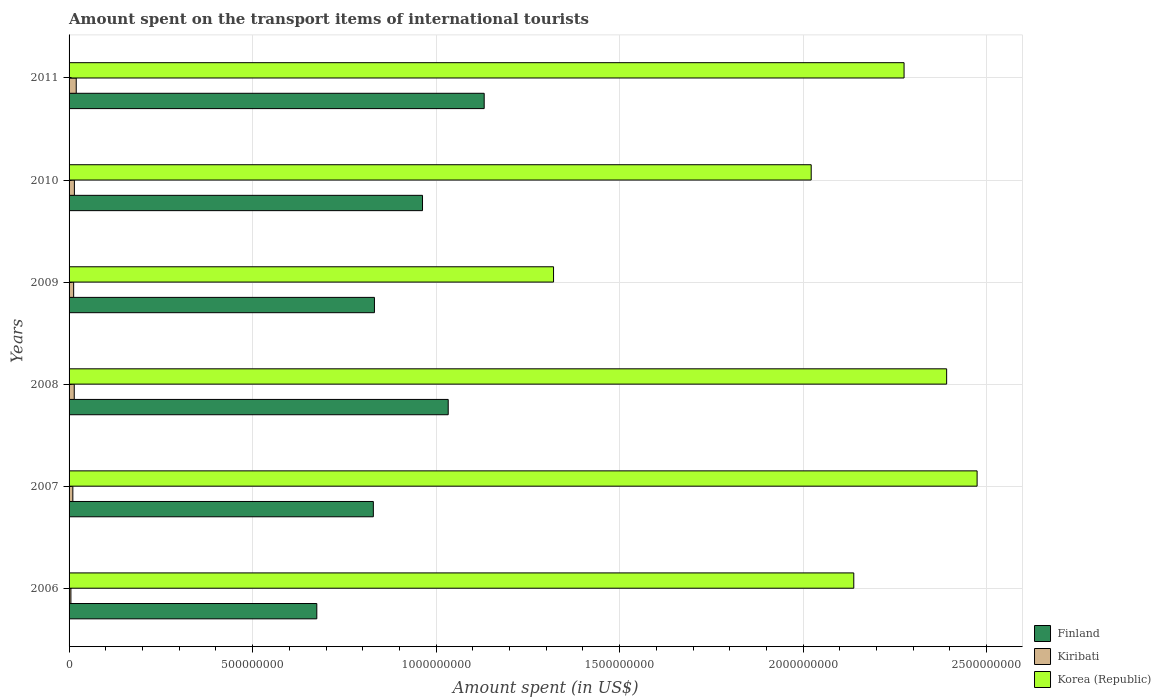How many groups of bars are there?
Make the answer very short. 6. Are the number of bars on each tick of the Y-axis equal?
Offer a very short reply. Yes. How many bars are there on the 5th tick from the top?
Your response must be concise. 3. How many bars are there on the 5th tick from the bottom?
Your answer should be very brief. 3. What is the label of the 1st group of bars from the top?
Ensure brevity in your answer.  2011. In how many cases, is the number of bars for a given year not equal to the number of legend labels?
Make the answer very short. 0. What is the amount spent on the transport items of international tourists in Korea (Republic) in 2007?
Offer a very short reply. 2.47e+09. Across all years, what is the maximum amount spent on the transport items of international tourists in Kiribati?
Offer a terse response. 1.95e+07. Across all years, what is the minimum amount spent on the transport items of international tourists in Kiribati?
Your answer should be very brief. 5.00e+06. In which year was the amount spent on the transport items of international tourists in Kiribati maximum?
Your answer should be compact. 2011. In which year was the amount spent on the transport items of international tourists in Finland minimum?
Offer a terse response. 2006. What is the total amount spent on the transport items of international tourists in Korea (Republic) in the graph?
Keep it short and to the point. 1.26e+1. What is the difference between the amount spent on the transport items of international tourists in Finland in 2007 and that in 2011?
Make the answer very short. -3.02e+08. What is the difference between the amount spent on the transport items of international tourists in Korea (Republic) in 2010 and the amount spent on the transport items of international tourists in Finland in 2007?
Provide a short and direct response. 1.19e+09. What is the average amount spent on the transport items of international tourists in Finland per year?
Offer a terse response. 9.10e+08. In the year 2010, what is the difference between the amount spent on the transport items of international tourists in Finland and amount spent on the transport items of international tourists in Kiribati?
Your answer should be very brief. 9.48e+08. In how many years, is the amount spent on the transport items of international tourists in Finland greater than 1800000000 US$?
Offer a terse response. 0. What is the ratio of the amount spent on the transport items of international tourists in Kiribati in 2008 to that in 2010?
Your answer should be compact. 0.97. What is the difference between the highest and the second highest amount spent on the transport items of international tourists in Finland?
Offer a terse response. 9.80e+07. What is the difference between the highest and the lowest amount spent on the transport items of international tourists in Korea (Republic)?
Offer a terse response. 1.15e+09. What does the 2nd bar from the top in 2011 represents?
Give a very brief answer. Kiribati. What is the difference between two consecutive major ticks on the X-axis?
Provide a short and direct response. 5.00e+08. Are the values on the major ticks of X-axis written in scientific E-notation?
Provide a succinct answer. No. Does the graph contain any zero values?
Offer a terse response. No. Does the graph contain grids?
Give a very brief answer. Yes. How many legend labels are there?
Your response must be concise. 3. What is the title of the graph?
Make the answer very short. Amount spent on the transport items of international tourists. Does "Bangladesh" appear as one of the legend labels in the graph?
Give a very brief answer. No. What is the label or title of the X-axis?
Your answer should be compact. Amount spent (in US$). What is the Amount spent (in US$) of Finland in 2006?
Offer a very short reply. 6.75e+08. What is the Amount spent (in US$) of Korea (Republic) in 2006?
Provide a short and direct response. 2.14e+09. What is the Amount spent (in US$) of Finland in 2007?
Your answer should be very brief. 8.29e+08. What is the Amount spent (in US$) in Kiribati in 2007?
Your response must be concise. 1.03e+07. What is the Amount spent (in US$) of Korea (Republic) in 2007?
Make the answer very short. 2.47e+09. What is the Amount spent (in US$) of Finland in 2008?
Provide a succinct answer. 1.03e+09. What is the Amount spent (in US$) of Kiribati in 2008?
Offer a terse response. 1.41e+07. What is the Amount spent (in US$) in Korea (Republic) in 2008?
Provide a succinct answer. 2.39e+09. What is the Amount spent (in US$) of Finland in 2009?
Provide a succinct answer. 8.32e+08. What is the Amount spent (in US$) in Kiribati in 2009?
Your response must be concise. 1.25e+07. What is the Amount spent (in US$) in Korea (Republic) in 2009?
Your answer should be compact. 1.32e+09. What is the Amount spent (in US$) in Finland in 2010?
Give a very brief answer. 9.63e+08. What is the Amount spent (in US$) in Kiribati in 2010?
Provide a short and direct response. 1.45e+07. What is the Amount spent (in US$) in Korea (Republic) in 2010?
Your answer should be compact. 2.02e+09. What is the Amount spent (in US$) in Finland in 2011?
Your answer should be very brief. 1.13e+09. What is the Amount spent (in US$) of Kiribati in 2011?
Provide a short and direct response. 1.95e+07. What is the Amount spent (in US$) in Korea (Republic) in 2011?
Your response must be concise. 2.28e+09. Across all years, what is the maximum Amount spent (in US$) in Finland?
Keep it short and to the point. 1.13e+09. Across all years, what is the maximum Amount spent (in US$) in Kiribati?
Give a very brief answer. 1.95e+07. Across all years, what is the maximum Amount spent (in US$) of Korea (Republic)?
Provide a succinct answer. 2.47e+09. Across all years, what is the minimum Amount spent (in US$) in Finland?
Offer a very short reply. 6.75e+08. Across all years, what is the minimum Amount spent (in US$) of Kiribati?
Keep it short and to the point. 5.00e+06. Across all years, what is the minimum Amount spent (in US$) of Korea (Republic)?
Keep it short and to the point. 1.32e+09. What is the total Amount spent (in US$) of Finland in the graph?
Provide a short and direct response. 5.46e+09. What is the total Amount spent (in US$) in Kiribati in the graph?
Your answer should be compact. 7.59e+07. What is the total Amount spent (in US$) in Korea (Republic) in the graph?
Provide a short and direct response. 1.26e+1. What is the difference between the Amount spent (in US$) of Finland in 2006 and that in 2007?
Keep it short and to the point. -1.54e+08. What is the difference between the Amount spent (in US$) of Kiribati in 2006 and that in 2007?
Provide a succinct answer. -5.30e+06. What is the difference between the Amount spent (in US$) of Korea (Republic) in 2006 and that in 2007?
Offer a very short reply. -3.36e+08. What is the difference between the Amount spent (in US$) in Finland in 2006 and that in 2008?
Your response must be concise. -3.58e+08. What is the difference between the Amount spent (in US$) of Kiribati in 2006 and that in 2008?
Offer a terse response. -9.10e+06. What is the difference between the Amount spent (in US$) of Korea (Republic) in 2006 and that in 2008?
Your answer should be very brief. -2.53e+08. What is the difference between the Amount spent (in US$) of Finland in 2006 and that in 2009?
Your answer should be very brief. -1.57e+08. What is the difference between the Amount spent (in US$) of Kiribati in 2006 and that in 2009?
Your answer should be compact. -7.50e+06. What is the difference between the Amount spent (in US$) in Korea (Republic) in 2006 and that in 2009?
Provide a short and direct response. 8.18e+08. What is the difference between the Amount spent (in US$) of Finland in 2006 and that in 2010?
Give a very brief answer. -2.88e+08. What is the difference between the Amount spent (in US$) of Kiribati in 2006 and that in 2010?
Offer a very short reply. -9.50e+06. What is the difference between the Amount spent (in US$) in Korea (Republic) in 2006 and that in 2010?
Keep it short and to the point. 1.16e+08. What is the difference between the Amount spent (in US$) in Finland in 2006 and that in 2011?
Your response must be concise. -4.56e+08. What is the difference between the Amount spent (in US$) of Kiribati in 2006 and that in 2011?
Offer a terse response. -1.45e+07. What is the difference between the Amount spent (in US$) in Korea (Republic) in 2006 and that in 2011?
Give a very brief answer. -1.37e+08. What is the difference between the Amount spent (in US$) in Finland in 2007 and that in 2008?
Provide a succinct answer. -2.04e+08. What is the difference between the Amount spent (in US$) of Kiribati in 2007 and that in 2008?
Offer a terse response. -3.80e+06. What is the difference between the Amount spent (in US$) of Korea (Republic) in 2007 and that in 2008?
Your answer should be very brief. 8.30e+07. What is the difference between the Amount spent (in US$) in Finland in 2007 and that in 2009?
Offer a very short reply. -3.00e+06. What is the difference between the Amount spent (in US$) in Kiribati in 2007 and that in 2009?
Your response must be concise. -2.20e+06. What is the difference between the Amount spent (in US$) of Korea (Republic) in 2007 and that in 2009?
Make the answer very short. 1.15e+09. What is the difference between the Amount spent (in US$) in Finland in 2007 and that in 2010?
Ensure brevity in your answer.  -1.34e+08. What is the difference between the Amount spent (in US$) of Kiribati in 2007 and that in 2010?
Provide a succinct answer. -4.20e+06. What is the difference between the Amount spent (in US$) of Korea (Republic) in 2007 and that in 2010?
Offer a terse response. 4.52e+08. What is the difference between the Amount spent (in US$) of Finland in 2007 and that in 2011?
Offer a very short reply. -3.02e+08. What is the difference between the Amount spent (in US$) in Kiribati in 2007 and that in 2011?
Your answer should be very brief. -9.20e+06. What is the difference between the Amount spent (in US$) in Korea (Republic) in 2007 and that in 2011?
Provide a short and direct response. 1.99e+08. What is the difference between the Amount spent (in US$) of Finland in 2008 and that in 2009?
Ensure brevity in your answer.  2.01e+08. What is the difference between the Amount spent (in US$) of Kiribati in 2008 and that in 2009?
Offer a very short reply. 1.60e+06. What is the difference between the Amount spent (in US$) in Korea (Republic) in 2008 and that in 2009?
Your answer should be compact. 1.07e+09. What is the difference between the Amount spent (in US$) of Finland in 2008 and that in 2010?
Provide a short and direct response. 7.00e+07. What is the difference between the Amount spent (in US$) in Kiribati in 2008 and that in 2010?
Offer a terse response. -4.00e+05. What is the difference between the Amount spent (in US$) of Korea (Republic) in 2008 and that in 2010?
Ensure brevity in your answer.  3.69e+08. What is the difference between the Amount spent (in US$) of Finland in 2008 and that in 2011?
Keep it short and to the point. -9.80e+07. What is the difference between the Amount spent (in US$) in Kiribati in 2008 and that in 2011?
Give a very brief answer. -5.40e+06. What is the difference between the Amount spent (in US$) of Korea (Republic) in 2008 and that in 2011?
Your response must be concise. 1.16e+08. What is the difference between the Amount spent (in US$) in Finland in 2009 and that in 2010?
Give a very brief answer. -1.31e+08. What is the difference between the Amount spent (in US$) in Kiribati in 2009 and that in 2010?
Offer a very short reply. -2.00e+06. What is the difference between the Amount spent (in US$) in Korea (Republic) in 2009 and that in 2010?
Keep it short and to the point. -7.02e+08. What is the difference between the Amount spent (in US$) of Finland in 2009 and that in 2011?
Keep it short and to the point. -2.99e+08. What is the difference between the Amount spent (in US$) in Kiribati in 2009 and that in 2011?
Provide a short and direct response. -7.00e+06. What is the difference between the Amount spent (in US$) of Korea (Republic) in 2009 and that in 2011?
Offer a very short reply. -9.55e+08. What is the difference between the Amount spent (in US$) of Finland in 2010 and that in 2011?
Your response must be concise. -1.68e+08. What is the difference between the Amount spent (in US$) in Kiribati in 2010 and that in 2011?
Your answer should be compact. -5.00e+06. What is the difference between the Amount spent (in US$) of Korea (Republic) in 2010 and that in 2011?
Offer a very short reply. -2.53e+08. What is the difference between the Amount spent (in US$) of Finland in 2006 and the Amount spent (in US$) of Kiribati in 2007?
Keep it short and to the point. 6.65e+08. What is the difference between the Amount spent (in US$) in Finland in 2006 and the Amount spent (in US$) in Korea (Republic) in 2007?
Provide a succinct answer. -1.80e+09. What is the difference between the Amount spent (in US$) of Kiribati in 2006 and the Amount spent (in US$) of Korea (Republic) in 2007?
Provide a succinct answer. -2.47e+09. What is the difference between the Amount spent (in US$) in Finland in 2006 and the Amount spent (in US$) in Kiribati in 2008?
Ensure brevity in your answer.  6.61e+08. What is the difference between the Amount spent (in US$) in Finland in 2006 and the Amount spent (in US$) in Korea (Republic) in 2008?
Offer a terse response. -1.72e+09. What is the difference between the Amount spent (in US$) of Kiribati in 2006 and the Amount spent (in US$) of Korea (Republic) in 2008?
Give a very brief answer. -2.39e+09. What is the difference between the Amount spent (in US$) in Finland in 2006 and the Amount spent (in US$) in Kiribati in 2009?
Offer a terse response. 6.62e+08. What is the difference between the Amount spent (in US$) in Finland in 2006 and the Amount spent (in US$) in Korea (Republic) in 2009?
Ensure brevity in your answer.  -6.45e+08. What is the difference between the Amount spent (in US$) in Kiribati in 2006 and the Amount spent (in US$) in Korea (Republic) in 2009?
Make the answer very short. -1.32e+09. What is the difference between the Amount spent (in US$) of Finland in 2006 and the Amount spent (in US$) of Kiribati in 2010?
Your answer should be very brief. 6.60e+08. What is the difference between the Amount spent (in US$) in Finland in 2006 and the Amount spent (in US$) in Korea (Republic) in 2010?
Keep it short and to the point. -1.35e+09. What is the difference between the Amount spent (in US$) in Kiribati in 2006 and the Amount spent (in US$) in Korea (Republic) in 2010?
Your answer should be very brief. -2.02e+09. What is the difference between the Amount spent (in US$) of Finland in 2006 and the Amount spent (in US$) of Kiribati in 2011?
Keep it short and to the point. 6.56e+08. What is the difference between the Amount spent (in US$) in Finland in 2006 and the Amount spent (in US$) in Korea (Republic) in 2011?
Your answer should be compact. -1.60e+09. What is the difference between the Amount spent (in US$) of Kiribati in 2006 and the Amount spent (in US$) of Korea (Republic) in 2011?
Provide a succinct answer. -2.27e+09. What is the difference between the Amount spent (in US$) in Finland in 2007 and the Amount spent (in US$) in Kiribati in 2008?
Your answer should be compact. 8.15e+08. What is the difference between the Amount spent (in US$) in Finland in 2007 and the Amount spent (in US$) in Korea (Republic) in 2008?
Keep it short and to the point. -1.56e+09. What is the difference between the Amount spent (in US$) in Kiribati in 2007 and the Amount spent (in US$) in Korea (Republic) in 2008?
Provide a short and direct response. -2.38e+09. What is the difference between the Amount spent (in US$) of Finland in 2007 and the Amount spent (in US$) of Kiribati in 2009?
Offer a very short reply. 8.16e+08. What is the difference between the Amount spent (in US$) of Finland in 2007 and the Amount spent (in US$) of Korea (Republic) in 2009?
Ensure brevity in your answer.  -4.91e+08. What is the difference between the Amount spent (in US$) of Kiribati in 2007 and the Amount spent (in US$) of Korea (Republic) in 2009?
Offer a very short reply. -1.31e+09. What is the difference between the Amount spent (in US$) of Finland in 2007 and the Amount spent (in US$) of Kiribati in 2010?
Your response must be concise. 8.14e+08. What is the difference between the Amount spent (in US$) in Finland in 2007 and the Amount spent (in US$) in Korea (Republic) in 2010?
Your answer should be compact. -1.19e+09. What is the difference between the Amount spent (in US$) of Kiribati in 2007 and the Amount spent (in US$) of Korea (Republic) in 2010?
Offer a very short reply. -2.01e+09. What is the difference between the Amount spent (in US$) in Finland in 2007 and the Amount spent (in US$) in Kiribati in 2011?
Offer a terse response. 8.10e+08. What is the difference between the Amount spent (in US$) of Finland in 2007 and the Amount spent (in US$) of Korea (Republic) in 2011?
Offer a very short reply. -1.45e+09. What is the difference between the Amount spent (in US$) of Kiribati in 2007 and the Amount spent (in US$) of Korea (Republic) in 2011?
Offer a very short reply. -2.26e+09. What is the difference between the Amount spent (in US$) of Finland in 2008 and the Amount spent (in US$) of Kiribati in 2009?
Offer a terse response. 1.02e+09. What is the difference between the Amount spent (in US$) in Finland in 2008 and the Amount spent (in US$) in Korea (Republic) in 2009?
Offer a terse response. -2.87e+08. What is the difference between the Amount spent (in US$) in Kiribati in 2008 and the Amount spent (in US$) in Korea (Republic) in 2009?
Your answer should be compact. -1.31e+09. What is the difference between the Amount spent (in US$) of Finland in 2008 and the Amount spent (in US$) of Kiribati in 2010?
Offer a very short reply. 1.02e+09. What is the difference between the Amount spent (in US$) in Finland in 2008 and the Amount spent (in US$) in Korea (Republic) in 2010?
Keep it short and to the point. -9.89e+08. What is the difference between the Amount spent (in US$) in Kiribati in 2008 and the Amount spent (in US$) in Korea (Republic) in 2010?
Ensure brevity in your answer.  -2.01e+09. What is the difference between the Amount spent (in US$) in Finland in 2008 and the Amount spent (in US$) in Kiribati in 2011?
Provide a short and direct response. 1.01e+09. What is the difference between the Amount spent (in US$) in Finland in 2008 and the Amount spent (in US$) in Korea (Republic) in 2011?
Give a very brief answer. -1.24e+09. What is the difference between the Amount spent (in US$) of Kiribati in 2008 and the Amount spent (in US$) of Korea (Republic) in 2011?
Provide a succinct answer. -2.26e+09. What is the difference between the Amount spent (in US$) in Finland in 2009 and the Amount spent (in US$) in Kiribati in 2010?
Ensure brevity in your answer.  8.18e+08. What is the difference between the Amount spent (in US$) of Finland in 2009 and the Amount spent (in US$) of Korea (Republic) in 2010?
Provide a succinct answer. -1.19e+09. What is the difference between the Amount spent (in US$) of Kiribati in 2009 and the Amount spent (in US$) of Korea (Republic) in 2010?
Ensure brevity in your answer.  -2.01e+09. What is the difference between the Amount spent (in US$) of Finland in 2009 and the Amount spent (in US$) of Kiribati in 2011?
Offer a very short reply. 8.12e+08. What is the difference between the Amount spent (in US$) of Finland in 2009 and the Amount spent (in US$) of Korea (Republic) in 2011?
Give a very brief answer. -1.44e+09. What is the difference between the Amount spent (in US$) of Kiribati in 2009 and the Amount spent (in US$) of Korea (Republic) in 2011?
Offer a very short reply. -2.26e+09. What is the difference between the Amount spent (in US$) of Finland in 2010 and the Amount spent (in US$) of Kiribati in 2011?
Give a very brief answer. 9.44e+08. What is the difference between the Amount spent (in US$) in Finland in 2010 and the Amount spent (in US$) in Korea (Republic) in 2011?
Ensure brevity in your answer.  -1.31e+09. What is the difference between the Amount spent (in US$) in Kiribati in 2010 and the Amount spent (in US$) in Korea (Republic) in 2011?
Make the answer very short. -2.26e+09. What is the average Amount spent (in US$) of Finland per year?
Your answer should be very brief. 9.10e+08. What is the average Amount spent (in US$) in Kiribati per year?
Your answer should be compact. 1.26e+07. What is the average Amount spent (in US$) in Korea (Republic) per year?
Ensure brevity in your answer.  2.10e+09. In the year 2006, what is the difference between the Amount spent (in US$) in Finland and Amount spent (in US$) in Kiribati?
Provide a succinct answer. 6.70e+08. In the year 2006, what is the difference between the Amount spent (in US$) of Finland and Amount spent (in US$) of Korea (Republic)?
Provide a short and direct response. -1.46e+09. In the year 2006, what is the difference between the Amount spent (in US$) of Kiribati and Amount spent (in US$) of Korea (Republic)?
Ensure brevity in your answer.  -2.13e+09. In the year 2007, what is the difference between the Amount spent (in US$) in Finland and Amount spent (in US$) in Kiribati?
Your answer should be compact. 8.19e+08. In the year 2007, what is the difference between the Amount spent (in US$) of Finland and Amount spent (in US$) of Korea (Republic)?
Provide a succinct answer. -1.64e+09. In the year 2007, what is the difference between the Amount spent (in US$) of Kiribati and Amount spent (in US$) of Korea (Republic)?
Give a very brief answer. -2.46e+09. In the year 2008, what is the difference between the Amount spent (in US$) in Finland and Amount spent (in US$) in Kiribati?
Keep it short and to the point. 1.02e+09. In the year 2008, what is the difference between the Amount spent (in US$) of Finland and Amount spent (in US$) of Korea (Republic)?
Offer a very short reply. -1.36e+09. In the year 2008, what is the difference between the Amount spent (in US$) of Kiribati and Amount spent (in US$) of Korea (Republic)?
Provide a succinct answer. -2.38e+09. In the year 2009, what is the difference between the Amount spent (in US$) in Finland and Amount spent (in US$) in Kiribati?
Ensure brevity in your answer.  8.20e+08. In the year 2009, what is the difference between the Amount spent (in US$) of Finland and Amount spent (in US$) of Korea (Republic)?
Keep it short and to the point. -4.88e+08. In the year 2009, what is the difference between the Amount spent (in US$) of Kiribati and Amount spent (in US$) of Korea (Republic)?
Ensure brevity in your answer.  -1.31e+09. In the year 2010, what is the difference between the Amount spent (in US$) of Finland and Amount spent (in US$) of Kiribati?
Your answer should be very brief. 9.48e+08. In the year 2010, what is the difference between the Amount spent (in US$) in Finland and Amount spent (in US$) in Korea (Republic)?
Offer a very short reply. -1.06e+09. In the year 2010, what is the difference between the Amount spent (in US$) in Kiribati and Amount spent (in US$) in Korea (Republic)?
Offer a terse response. -2.01e+09. In the year 2011, what is the difference between the Amount spent (in US$) of Finland and Amount spent (in US$) of Kiribati?
Your response must be concise. 1.11e+09. In the year 2011, what is the difference between the Amount spent (in US$) in Finland and Amount spent (in US$) in Korea (Republic)?
Offer a terse response. -1.14e+09. In the year 2011, what is the difference between the Amount spent (in US$) of Kiribati and Amount spent (in US$) of Korea (Republic)?
Keep it short and to the point. -2.26e+09. What is the ratio of the Amount spent (in US$) in Finland in 2006 to that in 2007?
Offer a terse response. 0.81. What is the ratio of the Amount spent (in US$) in Kiribati in 2006 to that in 2007?
Ensure brevity in your answer.  0.49. What is the ratio of the Amount spent (in US$) of Korea (Republic) in 2006 to that in 2007?
Ensure brevity in your answer.  0.86. What is the ratio of the Amount spent (in US$) of Finland in 2006 to that in 2008?
Keep it short and to the point. 0.65. What is the ratio of the Amount spent (in US$) in Kiribati in 2006 to that in 2008?
Your response must be concise. 0.35. What is the ratio of the Amount spent (in US$) of Korea (Republic) in 2006 to that in 2008?
Offer a very short reply. 0.89. What is the ratio of the Amount spent (in US$) of Finland in 2006 to that in 2009?
Your answer should be compact. 0.81. What is the ratio of the Amount spent (in US$) in Kiribati in 2006 to that in 2009?
Keep it short and to the point. 0.4. What is the ratio of the Amount spent (in US$) of Korea (Republic) in 2006 to that in 2009?
Provide a succinct answer. 1.62. What is the ratio of the Amount spent (in US$) in Finland in 2006 to that in 2010?
Keep it short and to the point. 0.7. What is the ratio of the Amount spent (in US$) of Kiribati in 2006 to that in 2010?
Provide a short and direct response. 0.34. What is the ratio of the Amount spent (in US$) in Korea (Republic) in 2006 to that in 2010?
Offer a very short reply. 1.06. What is the ratio of the Amount spent (in US$) in Finland in 2006 to that in 2011?
Give a very brief answer. 0.6. What is the ratio of the Amount spent (in US$) of Kiribati in 2006 to that in 2011?
Give a very brief answer. 0.26. What is the ratio of the Amount spent (in US$) in Korea (Republic) in 2006 to that in 2011?
Keep it short and to the point. 0.94. What is the ratio of the Amount spent (in US$) in Finland in 2007 to that in 2008?
Give a very brief answer. 0.8. What is the ratio of the Amount spent (in US$) of Kiribati in 2007 to that in 2008?
Offer a terse response. 0.73. What is the ratio of the Amount spent (in US$) in Korea (Republic) in 2007 to that in 2008?
Offer a terse response. 1.03. What is the ratio of the Amount spent (in US$) of Kiribati in 2007 to that in 2009?
Keep it short and to the point. 0.82. What is the ratio of the Amount spent (in US$) of Korea (Republic) in 2007 to that in 2009?
Provide a short and direct response. 1.87. What is the ratio of the Amount spent (in US$) in Finland in 2007 to that in 2010?
Make the answer very short. 0.86. What is the ratio of the Amount spent (in US$) in Kiribati in 2007 to that in 2010?
Offer a terse response. 0.71. What is the ratio of the Amount spent (in US$) of Korea (Republic) in 2007 to that in 2010?
Your answer should be very brief. 1.22. What is the ratio of the Amount spent (in US$) of Finland in 2007 to that in 2011?
Keep it short and to the point. 0.73. What is the ratio of the Amount spent (in US$) in Kiribati in 2007 to that in 2011?
Your response must be concise. 0.53. What is the ratio of the Amount spent (in US$) of Korea (Republic) in 2007 to that in 2011?
Give a very brief answer. 1.09. What is the ratio of the Amount spent (in US$) of Finland in 2008 to that in 2009?
Give a very brief answer. 1.24. What is the ratio of the Amount spent (in US$) of Kiribati in 2008 to that in 2009?
Your answer should be very brief. 1.13. What is the ratio of the Amount spent (in US$) in Korea (Republic) in 2008 to that in 2009?
Your response must be concise. 1.81. What is the ratio of the Amount spent (in US$) in Finland in 2008 to that in 2010?
Make the answer very short. 1.07. What is the ratio of the Amount spent (in US$) of Kiribati in 2008 to that in 2010?
Your answer should be compact. 0.97. What is the ratio of the Amount spent (in US$) in Korea (Republic) in 2008 to that in 2010?
Your response must be concise. 1.18. What is the ratio of the Amount spent (in US$) in Finland in 2008 to that in 2011?
Offer a very short reply. 0.91. What is the ratio of the Amount spent (in US$) of Kiribati in 2008 to that in 2011?
Your response must be concise. 0.72. What is the ratio of the Amount spent (in US$) of Korea (Republic) in 2008 to that in 2011?
Your answer should be very brief. 1.05. What is the ratio of the Amount spent (in US$) of Finland in 2009 to that in 2010?
Your response must be concise. 0.86. What is the ratio of the Amount spent (in US$) in Kiribati in 2009 to that in 2010?
Provide a short and direct response. 0.86. What is the ratio of the Amount spent (in US$) of Korea (Republic) in 2009 to that in 2010?
Provide a succinct answer. 0.65. What is the ratio of the Amount spent (in US$) of Finland in 2009 to that in 2011?
Make the answer very short. 0.74. What is the ratio of the Amount spent (in US$) in Kiribati in 2009 to that in 2011?
Your answer should be very brief. 0.64. What is the ratio of the Amount spent (in US$) of Korea (Republic) in 2009 to that in 2011?
Ensure brevity in your answer.  0.58. What is the ratio of the Amount spent (in US$) in Finland in 2010 to that in 2011?
Provide a short and direct response. 0.85. What is the ratio of the Amount spent (in US$) of Kiribati in 2010 to that in 2011?
Your answer should be compact. 0.74. What is the ratio of the Amount spent (in US$) of Korea (Republic) in 2010 to that in 2011?
Make the answer very short. 0.89. What is the difference between the highest and the second highest Amount spent (in US$) of Finland?
Your answer should be compact. 9.80e+07. What is the difference between the highest and the second highest Amount spent (in US$) of Kiribati?
Ensure brevity in your answer.  5.00e+06. What is the difference between the highest and the second highest Amount spent (in US$) of Korea (Republic)?
Provide a short and direct response. 8.30e+07. What is the difference between the highest and the lowest Amount spent (in US$) of Finland?
Your response must be concise. 4.56e+08. What is the difference between the highest and the lowest Amount spent (in US$) in Kiribati?
Your answer should be very brief. 1.45e+07. What is the difference between the highest and the lowest Amount spent (in US$) in Korea (Republic)?
Keep it short and to the point. 1.15e+09. 